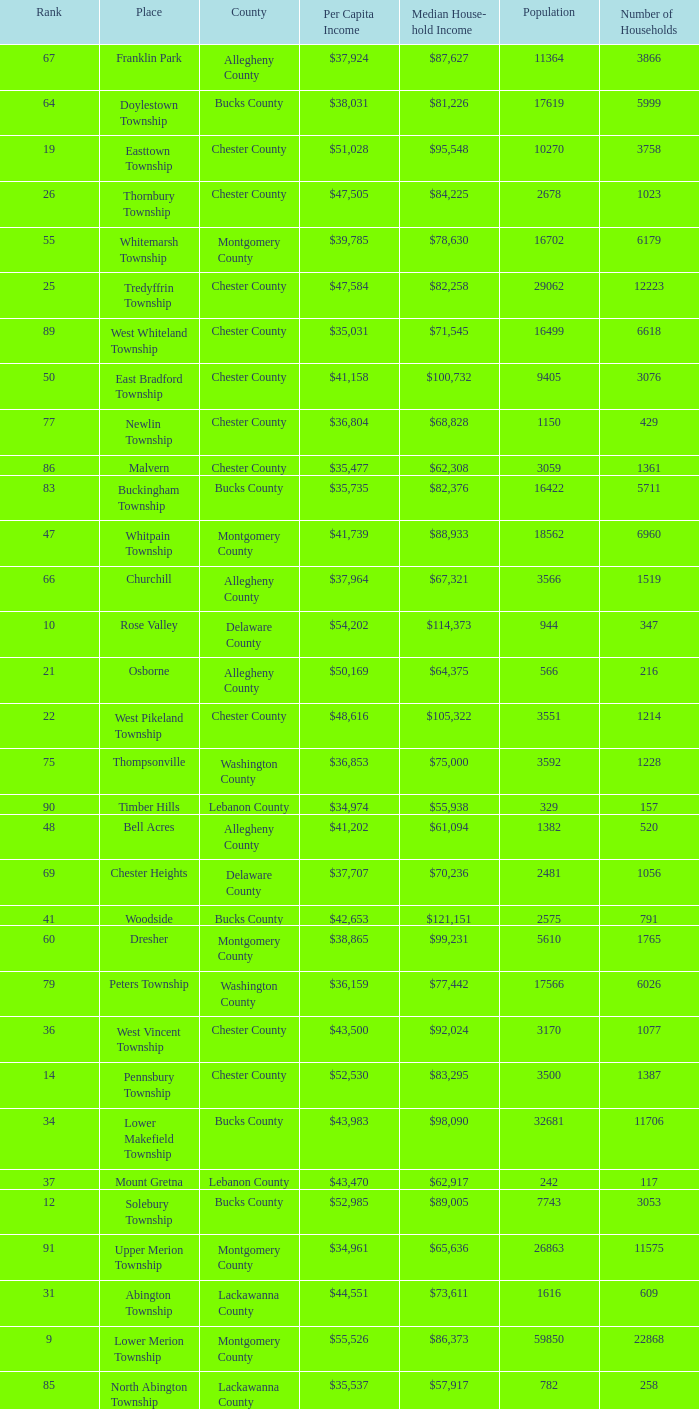Which county has a median household income of  $98,090? Bucks County. 